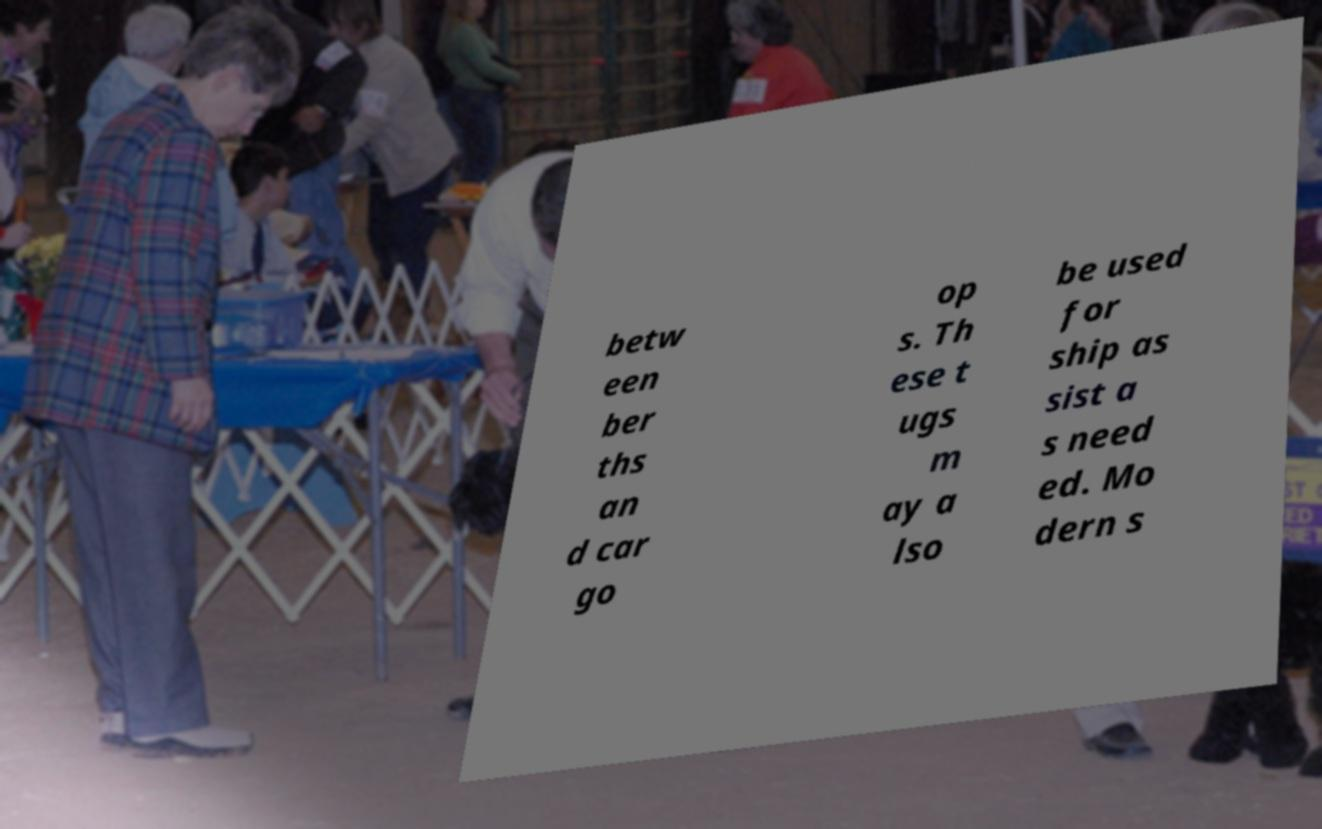Please read and relay the text visible in this image. What does it say? betw een ber ths an d car go op s. Th ese t ugs m ay a lso be used for ship as sist a s need ed. Mo dern s 